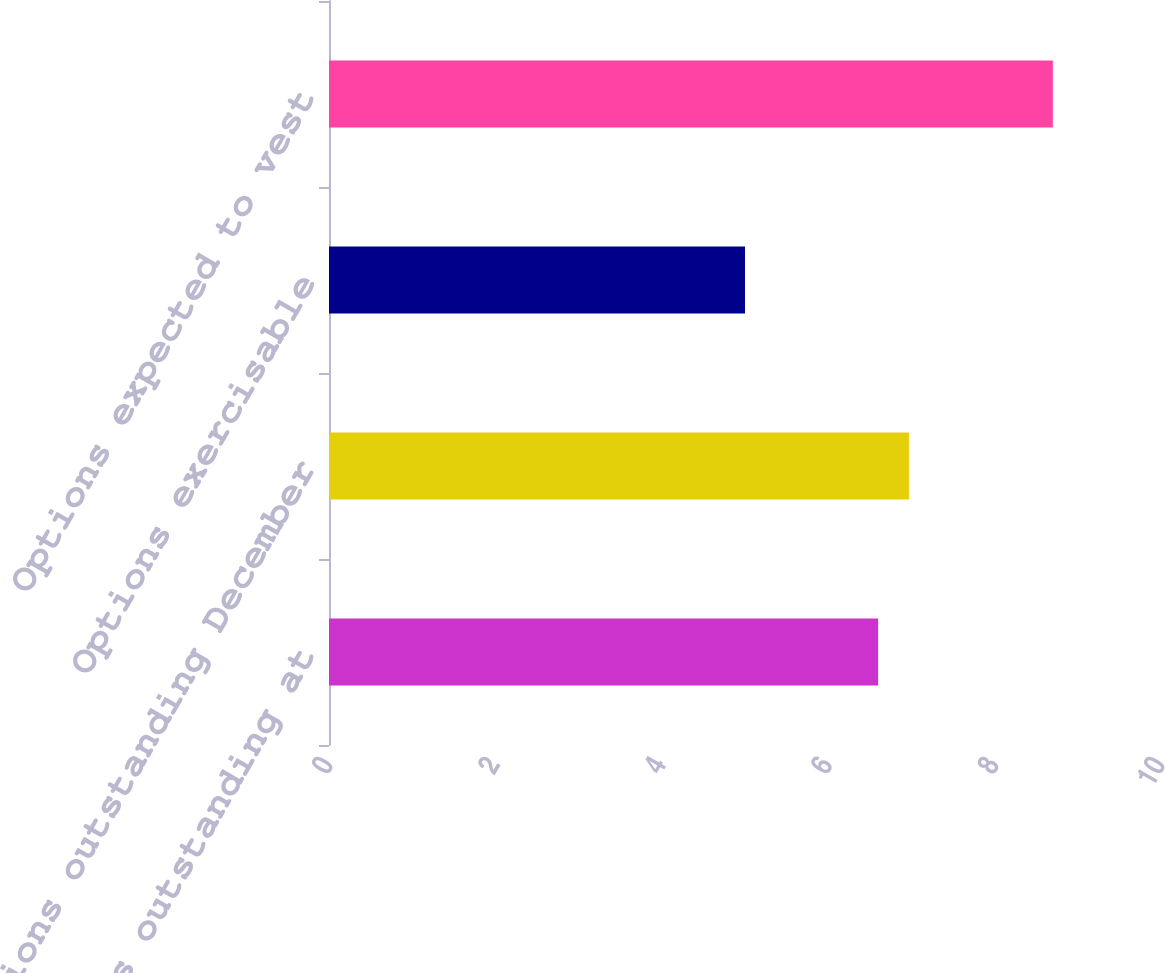Convert chart to OTSL. <chart><loc_0><loc_0><loc_500><loc_500><bar_chart><fcel>Options outstanding at<fcel>Options outstanding December<fcel>Options exercisable<fcel>Options expected to vest<nl><fcel>6.6<fcel>6.97<fcel>5<fcel>8.7<nl></chart> 